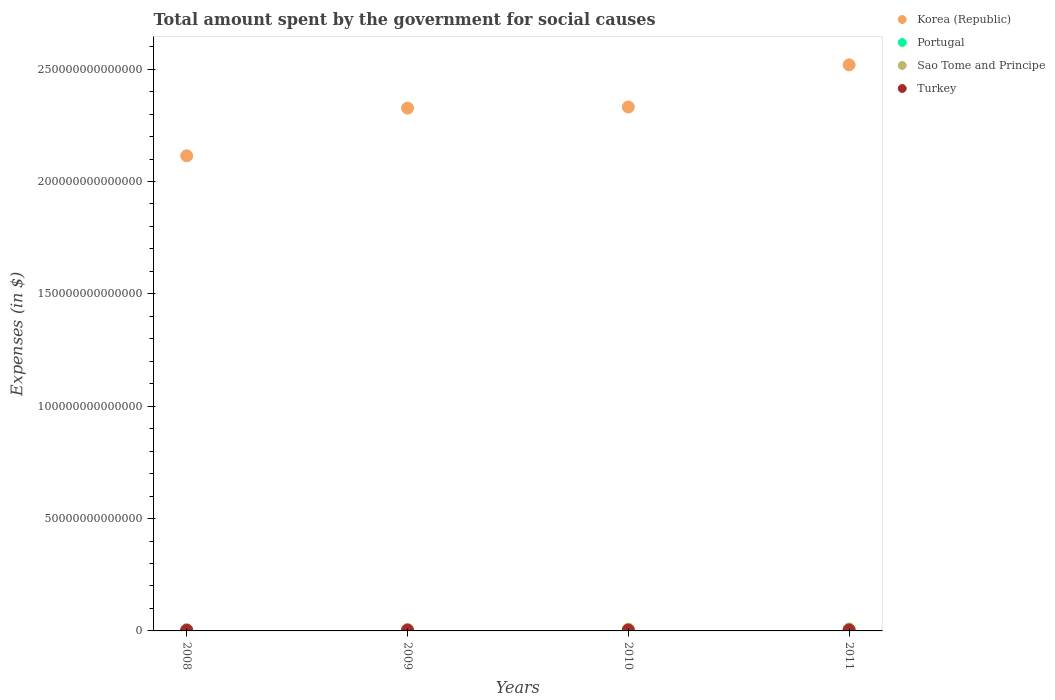What is the amount spent for social causes by the government in Sao Tome and Principe in 2011?
Your answer should be compact. 8.51e+11. Across all years, what is the maximum amount spent for social causes by the government in Turkey?
Your answer should be compact. 4.32e+11. Across all years, what is the minimum amount spent for social causes by the government in Turkey?
Your answer should be very brief. 2.97e+11. In which year was the amount spent for social causes by the government in Portugal maximum?
Keep it short and to the point. 2010. In which year was the amount spent for social causes by the government in Portugal minimum?
Give a very brief answer. 2008. What is the total amount spent for social causes by the government in Portugal in the graph?
Provide a short and direct response. 2.98e+11. What is the difference between the amount spent for social causes by the government in Turkey in 2009 and that in 2010?
Your response must be concise. -3.00e+1. What is the difference between the amount spent for social causes by the government in Portugal in 2009 and the amount spent for social causes by the government in Sao Tome and Principe in 2010?
Make the answer very short. -6.92e+11. What is the average amount spent for social causes by the government in Sao Tome and Principe per year?
Provide a succinct answer. 7.09e+11. In the year 2011, what is the difference between the amount spent for social causes by the government in Portugal and amount spent for social causes by the government in Turkey?
Keep it short and to the point. -3.57e+11. In how many years, is the amount spent for social causes by the government in Turkey greater than 190000000000000 $?
Your answer should be compact. 0. What is the ratio of the amount spent for social causes by the government in Portugal in 2008 to that in 2009?
Give a very brief answer. 0.94. What is the difference between the highest and the second highest amount spent for social causes by the government in Turkey?
Offer a terse response. 4.30e+1. What is the difference between the highest and the lowest amount spent for social causes by the government in Korea (Republic)?
Give a very brief answer. 4.05e+13. Is it the case that in every year, the sum of the amount spent for social causes by the government in Turkey and amount spent for social causes by the government in Korea (Republic)  is greater than the sum of amount spent for social causes by the government in Sao Tome and Principe and amount spent for social causes by the government in Portugal?
Make the answer very short. Yes. Does the amount spent for social causes by the government in Sao Tome and Principe monotonically increase over the years?
Your answer should be very brief. Yes. Is the amount spent for social causes by the government in Korea (Republic) strictly greater than the amount spent for social causes by the government in Turkey over the years?
Keep it short and to the point. Yes. How many dotlines are there?
Provide a short and direct response. 4. What is the difference between two consecutive major ticks on the Y-axis?
Provide a succinct answer. 5.00e+13. Are the values on the major ticks of Y-axis written in scientific E-notation?
Make the answer very short. No. Does the graph contain any zero values?
Give a very brief answer. No. Does the graph contain grids?
Give a very brief answer. No. Where does the legend appear in the graph?
Offer a terse response. Top right. What is the title of the graph?
Your response must be concise. Total amount spent by the government for social causes. Does "Germany" appear as one of the legend labels in the graph?
Your answer should be very brief. No. What is the label or title of the X-axis?
Provide a short and direct response. Years. What is the label or title of the Y-axis?
Your answer should be compact. Expenses (in $). What is the Expenses (in $) of Korea (Republic) in 2008?
Your response must be concise. 2.11e+14. What is the Expenses (in $) in Portugal in 2008?
Keep it short and to the point. 6.96e+1. What is the Expenses (in $) in Sao Tome and Principe in 2008?
Your response must be concise. 5.69e+11. What is the Expenses (in $) in Turkey in 2008?
Offer a very short reply. 2.97e+11. What is the Expenses (in $) in Korea (Republic) in 2009?
Give a very brief answer. 2.33e+14. What is the Expenses (in $) of Portugal in 2009?
Keep it short and to the point. 7.42e+1. What is the Expenses (in $) in Sao Tome and Principe in 2009?
Provide a succinct answer. 6.49e+11. What is the Expenses (in $) of Turkey in 2009?
Your answer should be very brief. 3.59e+11. What is the Expenses (in $) in Korea (Republic) in 2010?
Your answer should be compact. 2.33e+14. What is the Expenses (in $) in Portugal in 2010?
Make the answer very short. 7.84e+1. What is the Expenses (in $) of Sao Tome and Principe in 2010?
Ensure brevity in your answer.  7.67e+11. What is the Expenses (in $) in Turkey in 2010?
Offer a terse response. 3.89e+11. What is the Expenses (in $) of Korea (Republic) in 2011?
Ensure brevity in your answer.  2.52e+14. What is the Expenses (in $) in Portugal in 2011?
Offer a terse response. 7.56e+1. What is the Expenses (in $) in Sao Tome and Principe in 2011?
Offer a very short reply. 8.51e+11. What is the Expenses (in $) of Turkey in 2011?
Your answer should be very brief. 4.32e+11. Across all years, what is the maximum Expenses (in $) in Korea (Republic)?
Ensure brevity in your answer.  2.52e+14. Across all years, what is the maximum Expenses (in $) in Portugal?
Your answer should be very brief. 7.84e+1. Across all years, what is the maximum Expenses (in $) in Sao Tome and Principe?
Your answer should be very brief. 8.51e+11. Across all years, what is the maximum Expenses (in $) of Turkey?
Make the answer very short. 4.32e+11. Across all years, what is the minimum Expenses (in $) of Korea (Republic)?
Provide a succinct answer. 2.11e+14. Across all years, what is the minimum Expenses (in $) of Portugal?
Provide a succinct answer. 6.96e+1. Across all years, what is the minimum Expenses (in $) of Sao Tome and Principe?
Provide a short and direct response. 5.69e+11. Across all years, what is the minimum Expenses (in $) of Turkey?
Ensure brevity in your answer.  2.97e+11. What is the total Expenses (in $) of Korea (Republic) in the graph?
Give a very brief answer. 9.29e+14. What is the total Expenses (in $) of Portugal in the graph?
Keep it short and to the point. 2.98e+11. What is the total Expenses (in $) of Sao Tome and Principe in the graph?
Ensure brevity in your answer.  2.84e+12. What is the total Expenses (in $) in Turkey in the graph?
Your response must be concise. 1.48e+12. What is the difference between the Expenses (in $) of Korea (Republic) in 2008 and that in 2009?
Offer a terse response. -2.12e+13. What is the difference between the Expenses (in $) in Portugal in 2008 and that in 2009?
Your answer should be very brief. -4.59e+09. What is the difference between the Expenses (in $) in Sao Tome and Principe in 2008 and that in 2009?
Provide a short and direct response. -7.93e+1. What is the difference between the Expenses (in $) in Turkey in 2008 and that in 2009?
Keep it short and to the point. -6.24e+1. What is the difference between the Expenses (in $) in Korea (Republic) in 2008 and that in 2010?
Ensure brevity in your answer.  -2.17e+13. What is the difference between the Expenses (in $) of Portugal in 2008 and that in 2010?
Give a very brief answer. -8.71e+09. What is the difference between the Expenses (in $) of Sao Tome and Principe in 2008 and that in 2010?
Provide a short and direct response. -1.97e+11. What is the difference between the Expenses (in $) of Turkey in 2008 and that in 2010?
Provide a succinct answer. -9.24e+1. What is the difference between the Expenses (in $) of Korea (Republic) in 2008 and that in 2011?
Provide a succinct answer. -4.05e+13. What is the difference between the Expenses (in $) in Portugal in 2008 and that in 2011?
Your answer should be compact. -5.94e+09. What is the difference between the Expenses (in $) in Sao Tome and Principe in 2008 and that in 2011?
Your response must be concise. -2.81e+11. What is the difference between the Expenses (in $) in Turkey in 2008 and that in 2011?
Your response must be concise. -1.35e+11. What is the difference between the Expenses (in $) in Korea (Republic) in 2009 and that in 2010?
Make the answer very short. -4.79e+11. What is the difference between the Expenses (in $) in Portugal in 2009 and that in 2010?
Provide a short and direct response. -4.12e+09. What is the difference between the Expenses (in $) in Sao Tome and Principe in 2009 and that in 2010?
Offer a terse response. -1.18e+11. What is the difference between the Expenses (in $) of Turkey in 2009 and that in 2010?
Provide a succinct answer. -3.00e+1. What is the difference between the Expenses (in $) in Korea (Republic) in 2009 and that in 2011?
Your response must be concise. -1.92e+13. What is the difference between the Expenses (in $) in Portugal in 2009 and that in 2011?
Offer a very short reply. -1.35e+09. What is the difference between the Expenses (in $) of Sao Tome and Principe in 2009 and that in 2011?
Give a very brief answer. -2.02e+11. What is the difference between the Expenses (in $) in Turkey in 2009 and that in 2011?
Your answer should be compact. -7.30e+1. What is the difference between the Expenses (in $) of Korea (Republic) in 2010 and that in 2011?
Offer a very short reply. -1.88e+13. What is the difference between the Expenses (in $) in Portugal in 2010 and that in 2011?
Your answer should be compact. 2.77e+09. What is the difference between the Expenses (in $) in Sao Tome and Principe in 2010 and that in 2011?
Make the answer very short. -8.38e+1. What is the difference between the Expenses (in $) in Turkey in 2010 and that in 2011?
Your answer should be very brief. -4.30e+1. What is the difference between the Expenses (in $) of Korea (Republic) in 2008 and the Expenses (in $) of Portugal in 2009?
Your answer should be compact. 2.11e+14. What is the difference between the Expenses (in $) in Korea (Republic) in 2008 and the Expenses (in $) in Sao Tome and Principe in 2009?
Give a very brief answer. 2.11e+14. What is the difference between the Expenses (in $) of Korea (Republic) in 2008 and the Expenses (in $) of Turkey in 2009?
Offer a very short reply. 2.11e+14. What is the difference between the Expenses (in $) in Portugal in 2008 and the Expenses (in $) in Sao Tome and Principe in 2009?
Your answer should be very brief. -5.79e+11. What is the difference between the Expenses (in $) in Portugal in 2008 and the Expenses (in $) in Turkey in 2009?
Offer a terse response. -2.90e+11. What is the difference between the Expenses (in $) of Sao Tome and Principe in 2008 and the Expenses (in $) of Turkey in 2009?
Ensure brevity in your answer.  2.10e+11. What is the difference between the Expenses (in $) of Korea (Republic) in 2008 and the Expenses (in $) of Portugal in 2010?
Your answer should be very brief. 2.11e+14. What is the difference between the Expenses (in $) in Korea (Republic) in 2008 and the Expenses (in $) in Sao Tome and Principe in 2010?
Your answer should be compact. 2.11e+14. What is the difference between the Expenses (in $) of Korea (Republic) in 2008 and the Expenses (in $) of Turkey in 2010?
Your response must be concise. 2.11e+14. What is the difference between the Expenses (in $) of Portugal in 2008 and the Expenses (in $) of Sao Tome and Principe in 2010?
Your response must be concise. -6.97e+11. What is the difference between the Expenses (in $) of Portugal in 2008 and the Expenses (in $) of Turkey in 2010?
Your answer should be very brief. -3.20e+11. What is the difference between the Expenses (in $) in Sao Tome and Principe in 2008 and the Expenses (in $) in Turkey in 2010?
Your answer should be compact. 1.80e+11. What is the difference between the Expenses (in $) of Korea (Republic) in 2008 and the Expenses (in $) of Portugal in 2011?
Keep it short and to the point. 2.11e+14. What is the difference between the Expenses (in $) of Korea (Republic) in 2008 and the Expenses (in $) of Sao Tome and Principe in 2011?
Your response must be concise. 2.11e+14. What is the difference between the Expenses (in $) of Korea (Republic) in 2008 and the Expenses (in $) of Turkey in 2011?
Make the answer very short. 2.11e+14. What is the difference between the Expenses (in $) of Portugal in 2008 and the Expenses (in $) of Sao Tome and Principe in 2011?
Your response must be concise. -7.81e+11. What is the difference between the Expenses (in $) in Portugal in 2008 and the Expenses (in $) in Turkey in 2011?
Your answer should be compact. -3.63e+11. What is the difference between the Expenses (in $) in Sao Tome and Principe in 2008 and the Expenses (in $) in Turkey in 2011?
Your answer should be compact. 1.37e+11. What is the difference between the Expenses (in $) in Korea (Republic) in 2009 and the Expenses (in $) in Portugal in 2010?
Provide a succinct answer. 2.33e+14. What is the difference between the Expenses (in $) of Korea (Republic) in 2009 and the Expenses (in $) of Sao Tome and Principe in 2010?
Keep it short and to the point. 2.32e+14. What is the difference between the Expenses (in $) of Korea (Republic) in 2009 and the Expenses (in $) of Turkey in 2010?
Ensure brevity in your answer.  2.32e+14. What is the difference between the Expenses (in $) of Portugal in 2009 and the Expenses (in $) of Sao Tome and Principe in 2010?
Offer a terse response. -6.92e+11. What is the difference between the Expenses (in $) in Portugal in 2009 and the Expenses (in $) in Turkey in 2010?
Make the answer very short. -3.15e+11. What is the difference between the Expenses (in $) of Sao Tome and Principe in 2009 and the Expenses (in $) of Turkey in 2010?
Your answer should be compact. 2.60e+11. What is the difference between the Expenses (in $) in Korea (Republic) in 2009 and the Expenses (in $) in Portugal in 2011?
Ensure brevity in your answer.  2.33e+14. What is the difference between the Expenses (in $) in Korea (Republic) in 2009 and the Expenses (in $) in Sao Tome and Principe in 2011?
Offer a very short reply. 2.32e+14. What is the difference between the Expenses (in $) in Korea (Republic) in 2009 and the Expenses (in $) in Turkey in 2011?
Provide a short and direct response. 2.32e+14. What is the difference between the Expenses (in $) in Portugal in 2009 and the Expenses (in $) in Sao Tome and Principe in 2011?
Your answer should be compact. -7.76e+11. What is the difference between the Expenses (in $) in Portugal in 2009 and the Expenses (in $) in Turkey in 2011?
Offer a terse response. -3.58e+11. What is the difference between the Expenses (in $) in Sao Tome and Principe in 2009 and the Expenses (in $) in Turkey in 2011?
Provide a succinct answer. 2.16e+11. What is the difference between the Expenses (in $) of Korea (Republic) in 2010 and the Expenses (in $) of Portugal in 2011?
Give a very brief answer. 2.33e+14. What is the difference between the Expenses (in $) in Korea (Republic) in 2010 and the Expenses (in $) in Sao Tome and Principe in 2011?
Offer a terse response. 2.32e+14. What is the difference between the Expenses (in $) of Korea (Republic) in 2010 and the Expenses (in $) of Turkey in 2011?
Your response must be concise. 2.33e+14. What is the difference between the Expenses (in $) of Portugal in 2010 and the Expenses (in $) of Sao Tome and Principe in 2011?
Your response must be concise. -7.72e+11. What is the difference between the Expenses (in $) in Portugal in 2010 and the Expenses (in $) in Turkey in 2011?
Ensure brevity in your answer.  -3.54e+11. What is the difference between the Expenses (in $) in Sao Tome and Principe in 2010 and the Expenses (in $) in Turkey in 2011?
Offer a very short reply. 3.34e+11. What is the average Expenses (in $) in Korea (Republic) per year?
Give a very brief answer. 2.32e+14. What is the average Expenses (in $) of Portugal per year?
Give a very brief answer. 7.45e+1. What is the average Expenses (in $) of Sao Tome and Principe per year?
Your answer should be compact. 7.09e+11. What is the average Expenses (in $) of Turkey per year?
Provide a short and direct response. 3.69e+11. In the year 2008, what is the difference between the Expenses (in $) of Korea (Republic) and Expenses (in $) of Portugal?
Keep it short and to the point. 2.11e+14. In the year 2008, what is the difference between the Expenses (in $) of Korea (Republic) and Expenses (in $) of Sao Tome and Principe?
Make the answer very short. 2.11e+14. In the year 2008, what is the difference between the Expenses (in $) in Korea (Republic) and Expenses (in $) in Turkey?
Your answer should be very brief. 2.11e+14. In the year 2008, what is the difference between the Expenses (in $) of Portugal and Expenses (in $) of Sao Tome and Principe?
Provide a short and direct response. -5.00e+11. In the year 2008, what is the difference between the Expenses (in $) in Portugal and Expenses (in $) in Turkey?
Provide a short and direct response. -2.27e+11. In the year 2008, what is the difference between the Expenses (in $) in Sao Tome and Principe and Expenses (in $) in Turkey?
Your answer should be compact. 2.73e+11. In the year 2009, what is the difference between the Expenses (in $) in Korea (Republic) and Expenses (in $) in Portugal?
Offer a terse response. 2.33e+14. In the year 2009, what is the difference between the Expenses (in $) of Korea (Republic) and Expenses (in $) of Sao Tome and Principe?
Your answer should be very brief. 2.32e+14. In the year 2009, what is the difference between the Expenses (in $) in Korea (Republic) and Expenses (in $) in Turkey?
Your answer should be very brief. 2.32e+14. In the year 2009, what is the difference between the Expenses (in $) in Portugal and Expenses (in $) in Sao Tome and Principe?
Offer a terse response. -5.75e+11. In the year 2009, what is the difference between the Expenses (in $) in Portugal and Expenses (in $) in Turkey?
Offer a very short reply. -2.85e+11. In the year 2009, what is the difference between the Expenses (in $) in Sao Tome and Principe and Expenses (in $) in Turkey?
Your response must be concise. 2.90e+11. In the year 2010, what is the difference between the Expenses (in $) of Korea (Republic) and Expenses (in $) of Portugal?
Offer a terse response. 2.33e+14. In the year 2010, what is the difference between the Expenses (in $) of Korea (Republic) and Expenses (in $) of Sao Tome and Principe?
Your response must be concise. 2.32e+14. In the year 2010, what is the difference between the Expenses (in $) of Korea (Republic) and Expenses (in $) of Turkey?
Ensure brevity in your answer.  2.33e+14. In the year 2010, what is the difference between the Expenses (in $) of Portugal and Expenses (in $) of Sao Tome and Principe?
Your answer should be compact. -6.88e+11. In the year 2010, what is the difference between the Expenses (in $) of Portugal and Expenses (in $) of Turkey?
Provide a short and direct response. -3.11e+11. In the year 2010, what is the difference between the Expenses (in $) in Sao Tome and Principe and Expenses (in $) in Turkey?
Provide a short and direct response. 3.77e+11. In the year 2011, what is the difference between the Expenses (in $) in Korea (Republic) and Expenses (in $) in Portugal?
Make the answer very short. 2.52e+14. In the year 2011, what is the difference between the Expenses (in $) in Korea (Republic) and Expenses (in $) in Sao Tome and Principe?
Give a very brief answer. 2.51e+14. In the year 2011, what is the difference between the Expenses (in $) of Korea (Republic) and Expenses (in $) of Turkey?
Give a very brief answer. 2.51e+14. In the year 2011, what is the difference between the Expenses (in $) in Portugal and Expenses (in $) in Sao Tome and Principe?
Your response must be concise. -7.75e+11. In the year 2011, what is the difference between the Expenses (in $) of Portugal and Expenses (in $) of Turkey?
Your response must be concise. -3.57e+11. In the year 2011, what is the difference between the Expenses (in $) of Sao Tome and Principe and Expenses (in $) of Turkey?
Make the answer very short. 4.18e+11. What is the ratio of the Expenses (in $) of Korea (Republic) in 2008 to that in 2009?
Provide a short and direct response. 0.91. What is the ratio of the Expenses (in $) of Portugal in 2008 to that in 2009?
Provide a succinct answer. 0.94. What is the ratio of the Expenses (in $) in Sao Tome and Principe in 2008 to that in 2009?
Offer a very short reply. 0.88. What is the ratio of the Expenses (in $) of Turkey in 2008 to that in 2009?
Provide a succinct answer. 0.83. What is the ratio of the Expenses (in $) in Korea (Republic) in 2008 to that in 2010?
Your response must be concise. 0.91. What is the ratio of the Expenses (in $) of Portugal in 2008 to that in 2010?
Your answer should be very brief. 0.89. What is the ratio of the Expenses (in $) of Sao Tome and Principe in 2008 to that in 2010?
Your answer should be compact. 0.74. What is the ratio of the Expenses (in $) in Turkey in 2008 to that in 2010?
Give a very brief answer. 0.76. What is the ratio of the Expenses (in $) of Korea (Republic) in 2008 to that in 2011?
Offer a very short reply. 0.84. What is the ratio of the Expenses (in $) in Portugal in 2008 to that in 2011?
Your answer should be very brief. 0.92. What is the ratio of the Expenses (in $) in Sao Tome and Principe in 2008 to that in 2011?
Your answer should be very brief. 0.67. What is the ratio of the Expenses (in $) of Turkey in 2008 to that in 2011?
Your response must be concise. 0.69. What is the ratio of the Expenses (in $) in Korea (Republic) in 2009 to that in 2010?
Your response must be concise. 1. What is the ratio of the Expenses (in $) in Portugal in 2009 to that in 2010?
Provide a succinct answer. 0.95. What is the ratio of the Expenses (in $) in Sao Tome and Principe in 2009 to that in 2010?
Offer a terse response. 0.85. What is the ratio of the Expenses (in $) of Turkey in 2009 to that in 2010?
Give a very brief answer. 0.92. What is the ratio of the Expenses (in $) in Korea (Republic) in 2009 to that in 2011?
Offer a very short reply. 0.92. What is the ratio of the Expenses (in $) in Portugal in 2009 to that in 2011?
Your answer should be very brief. 0.98. What is the ratio of the Expenses (in $) in Sao Tome and Principe in 2009 to that in 2011?
Keep it short and to the point. 0.76. What is the ratio of the Expenses (in $) of Turkey in 2009 to that in 2011?
Offer a very short reply. 0.83. What is the ratio of the Expenses (in $) in Korea (Republic) in 2010 to that in 2011?
Your response must be concise. 0.93. What is the ratio of the Expenses (in $) of Portugal in 2010 to that in 2011?
Make the answer very short. 1.04. What is the ratio of the Expenses (in $) of Sao Tome and Principe in 2010 to that in 2011?
Give a very brief answer. 0.9. What is the ratio of the Expenses (in $) of Turkey in 2010 to that in 2011?
Your response must be concise. 0.9. What is the difference between the highest and the second highest Expenses (in $) in Korea (Republic)?
Your answer should be compact. 1.88e+13. What is the difference between the highest and the second highest Expenses (in $) of Portugal?
Your answer should be compact. 2.77e+09. What is the difference between the highest and the second highest Expenses (in $) of Sao Tome and Principe?
Make the answer very short. 8.38e+1. What is the difference between the highest and the second highest Expenses (in $) of Turkey?
Ensure brevity in your answer.  4.30e+1. What is the difference between the highest and the lowest Expenses (in $) in Korea (Republic)?
Keep it short and to the point. 4.05e+13. What is the difference between the highest and the lowest Expenses (in $) of Portugal?
Make the answer very short. 8.71e+09. What is the difference between the highest and the lowest Expenses (in $) of Sao Tome and Principe?
Give a very brief answer. 2.81e+11. What is the difference between the highest and the lowest Expenses (in $) in Turkey?
Provide a succinct answer. 1.35e+11. 